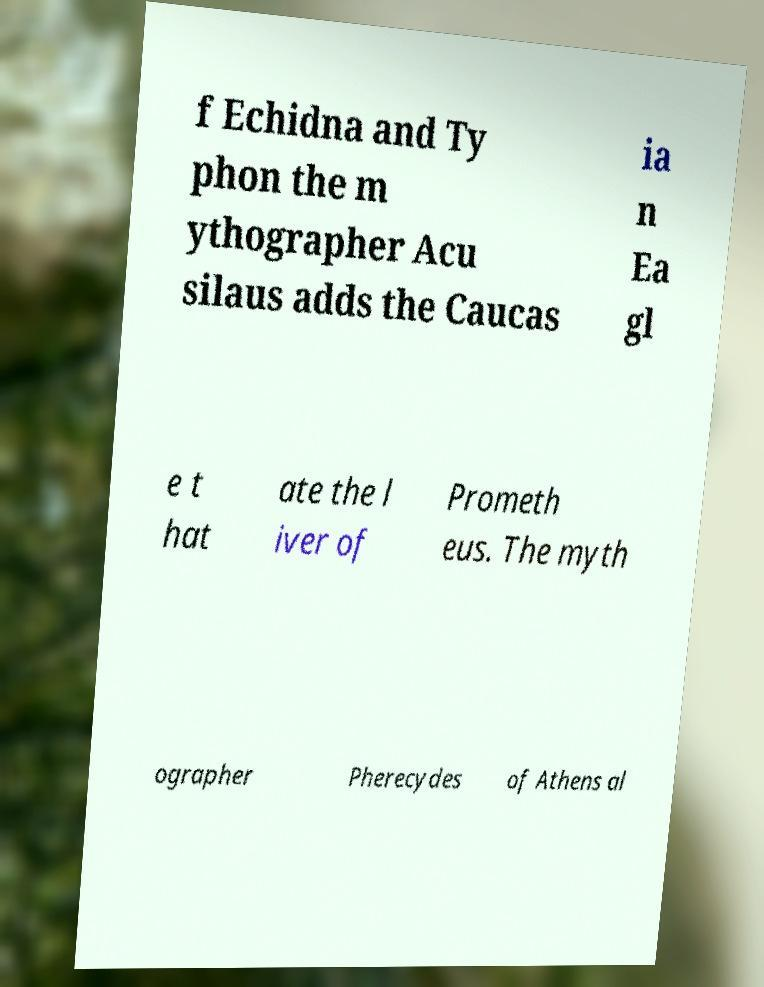Can you read and provide the text displayed in the image?This photo seems to have some interesting text. Can you extract and type it out for me? f Echidna and Ty phon the m ythographer Acu silaus adds the Caucas ia n Ea gl e t hat ate the l iver of Prometh eus. The myth ographer Pherecydes of Athens al 